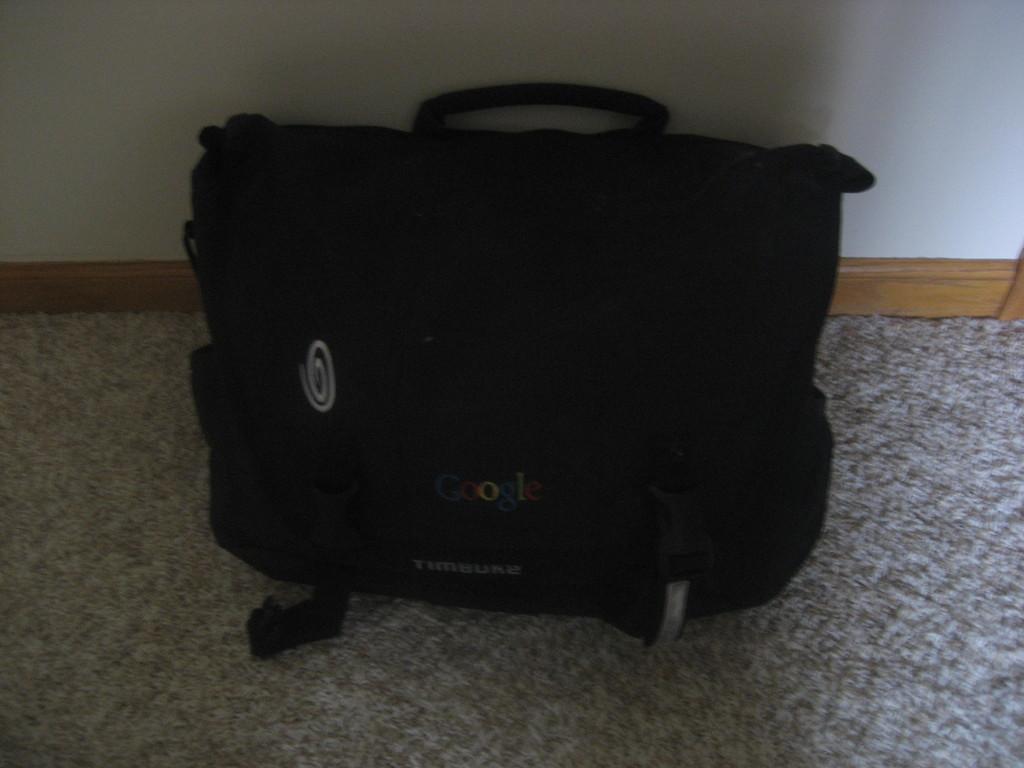How would you summarize this image in a sentence or two? The picture consists of a bag which is in black colour and text written on it. It is placed on the carpet and behind the bag there is a wall. 